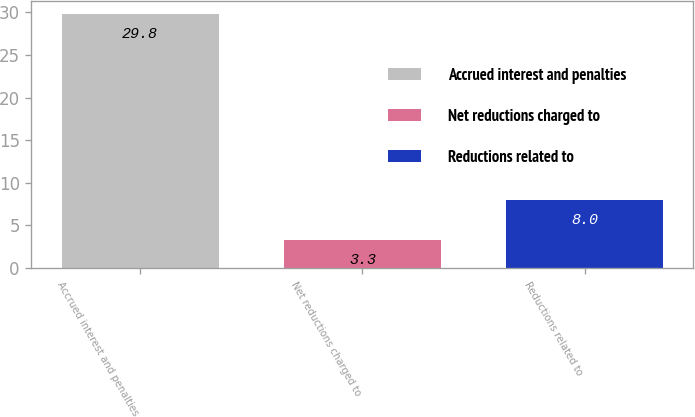Convert chart. <chart><loc_0><loc_0><loc_500><loc_500><bar_chart><fcel>Accrued interest and penalties<fcel>Net reductions charged to<fcel>Reductions related to<nl><fcel>29.8<fcel>3.3<fcel>8<nl></chart> 